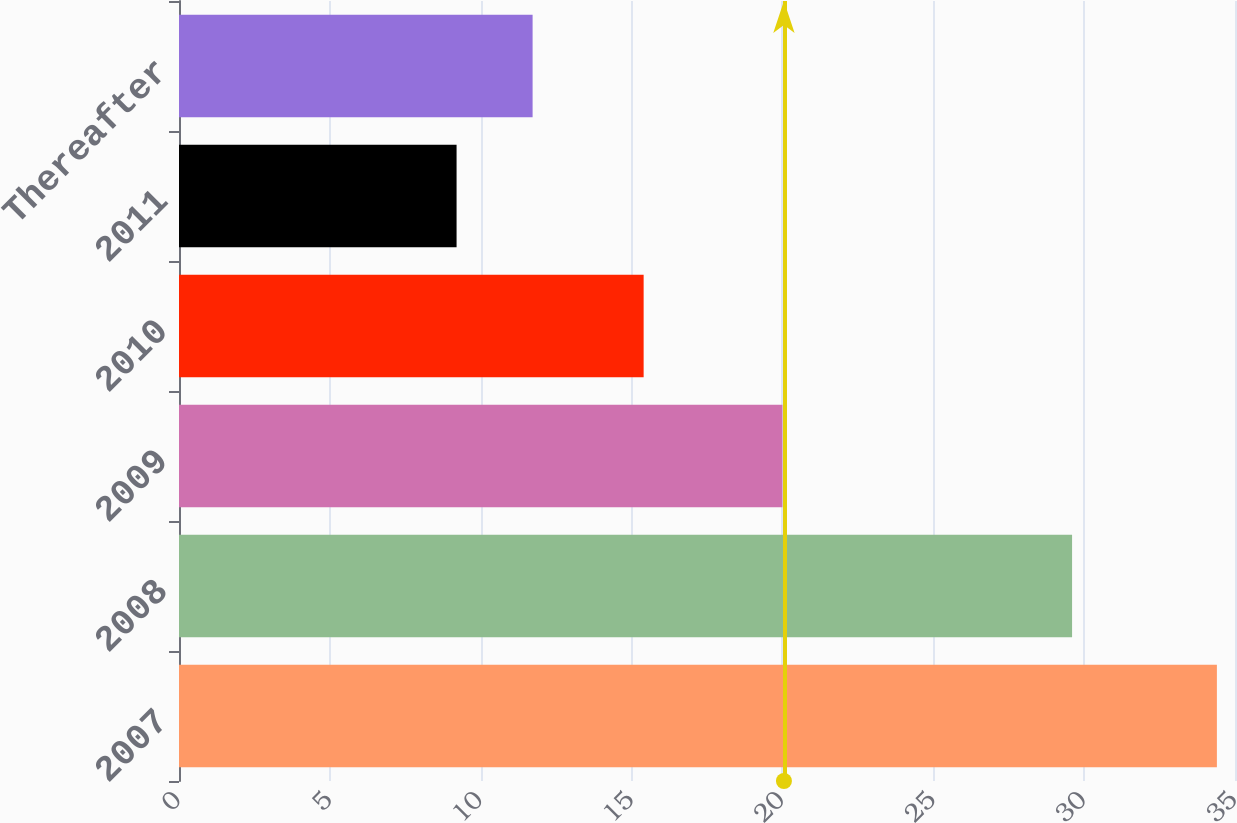Convert chart. <chart><loc_0><loc_0><loc_500><loc_500><bar_chart><fcel>2007<fcel>2008<fcel>2009<fcel>2010<fcel>2011<fcel>Thereafter<nl><fcel>34.4<fcel>29.6<fcel>20<fcel>15.4<fcel>9.2<fcel>11.72<nl></chart> 